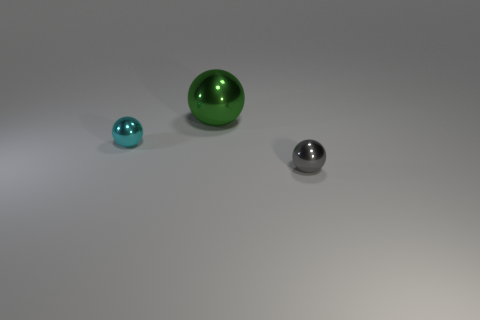Can you tell me the colors of the objects in the image? Certainly! In the image, there are three spherical objects, each with a distinct color. The smallest sphere is a pale blue, the medium-sized one is a vibrant green, and the largest sphere is gray, reflecting some of the environment's light and displaying shades of white and darker grays. 